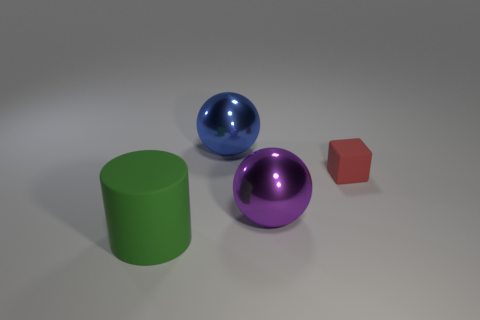What is the size of the rubber object that is on the right side of the big thing that is in front of the metal sphere in front of the red rubber block?
Your answer should be very brief. Small. Is the number of large blue balls that are to the right of the large blue shiny ball the same as the number of small cyan matte spheres?
Offer a very short reply. Yes. Are there any other things that are the same shape as the tiny matte object?
Offer a terse response. No. Do the green matte object and the large metal object in front of the small red matte thing have the same shape?
Keep it short and to the point. No. There is another metal object that is the same shape as the big purple thing; what is its size?
Provide a short and direct response. Large. What number of other things are there of the same material as the blue sphere
Give a very brief answer. 1. What is the block made of?
Your answer should be very brief. Rubber. Do the rubber object to the right of the big rubber thing and the big ball behind the small matte thing have the same color?
Provide a short and direct response. No. Is the number of large purple shiny objects in front of the tiny matte object greater than the number of big spheres?
Give a very brief answer. No. How many other things are the same color as the matte cylinder?
Your answer should be very brief. 0. 